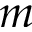Convert formula to latex. <formula><loc_0><loc_0><loc_500><loc_500>m</formula> 